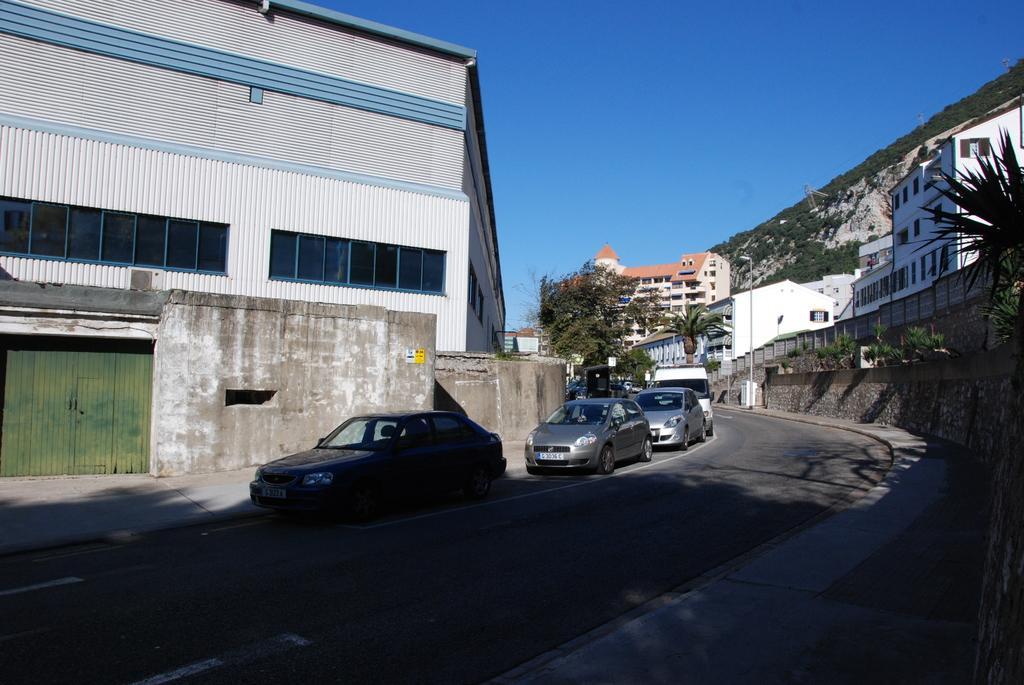Please provide a concise description of this image. The picture is taken outside the city. In the foreground of the picture there are cars, road, pavement and plant. In the center of the picture there are buildings, trees, street light and hill. Sky is sunny. 